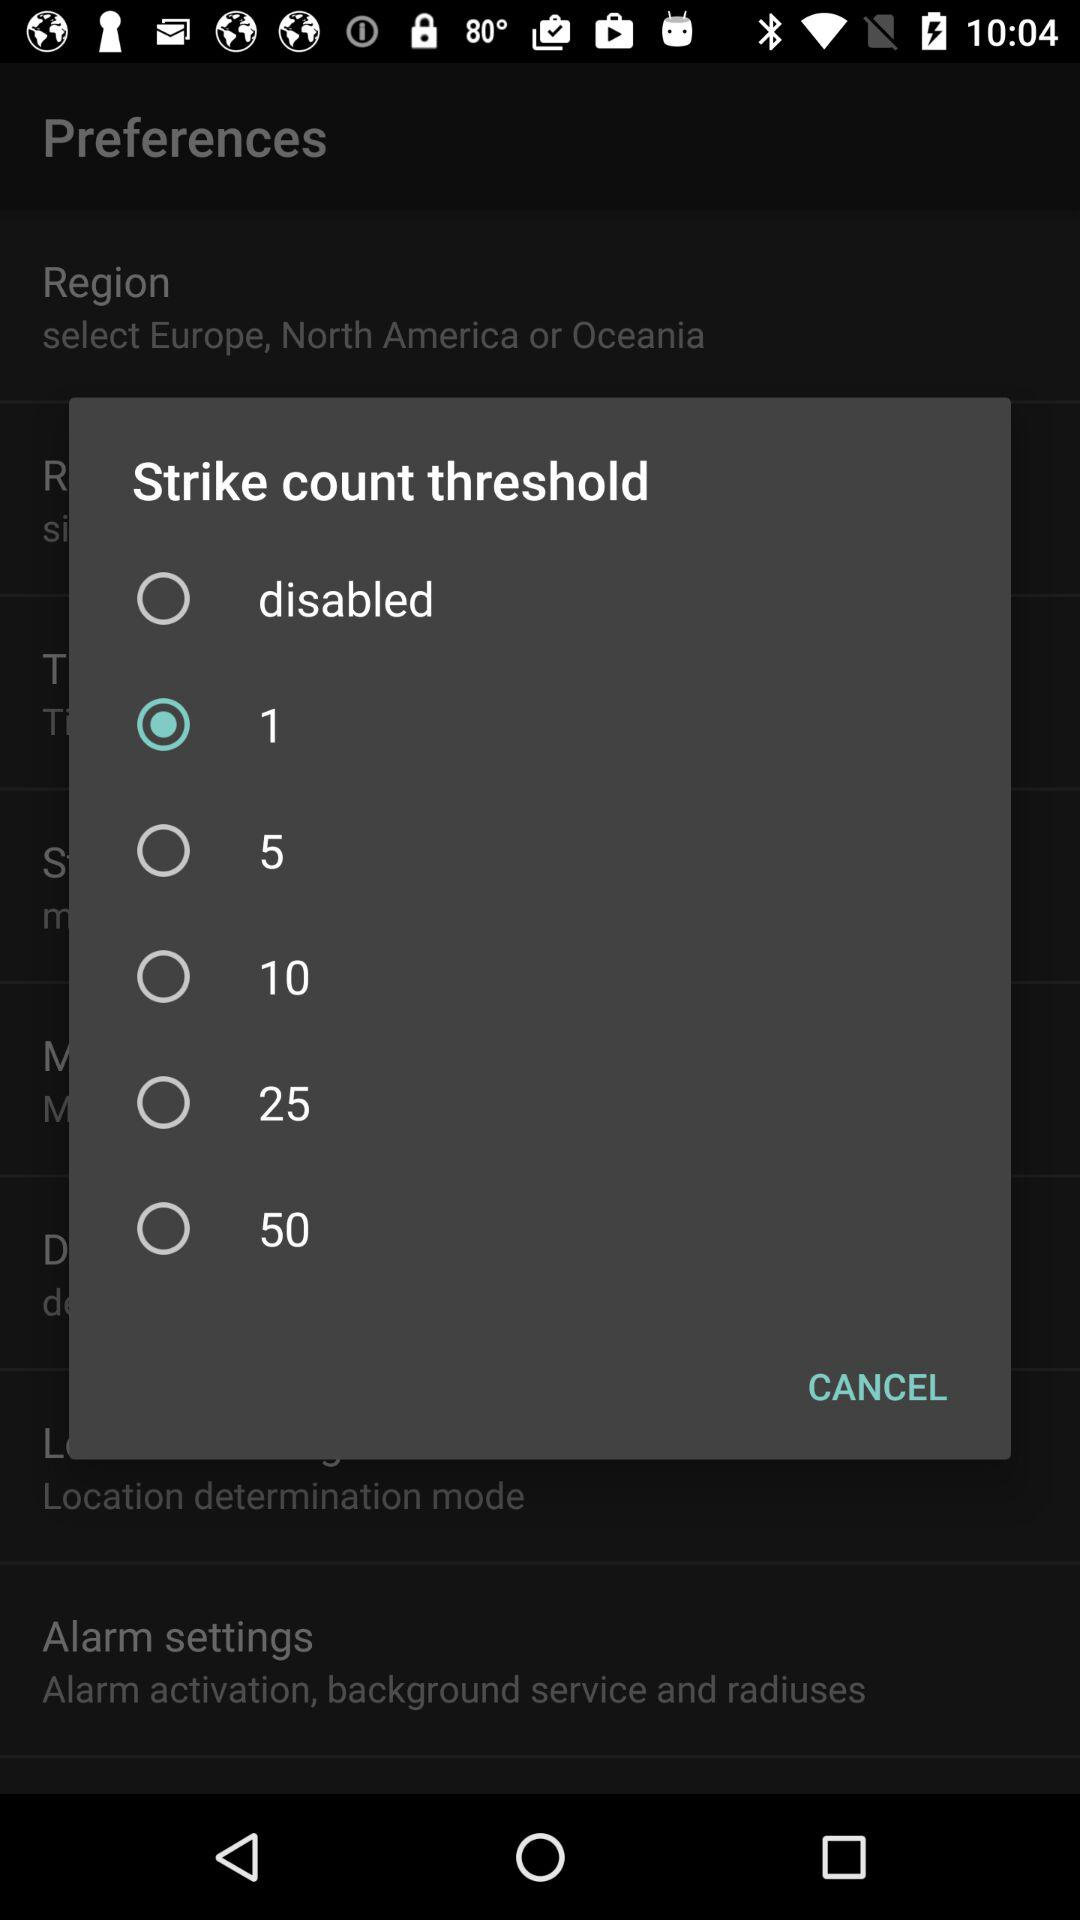Which option is selected? The selected option is "1". 